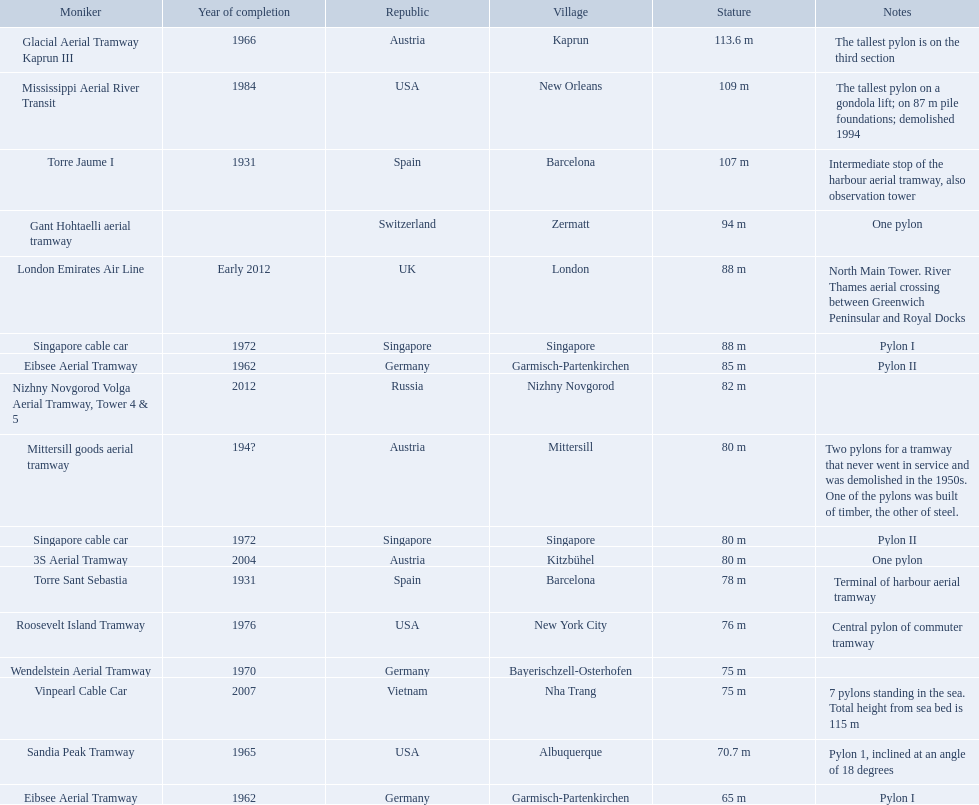Which aerial lifts are over 100 meters tall? Glacial Aerial Tramway Kaprun III, Mississippi Aerial River Transit, Torre Jaume I. Which of those was built last? Mississippi Aerial River Transit. And what is its total height? 109 m. 